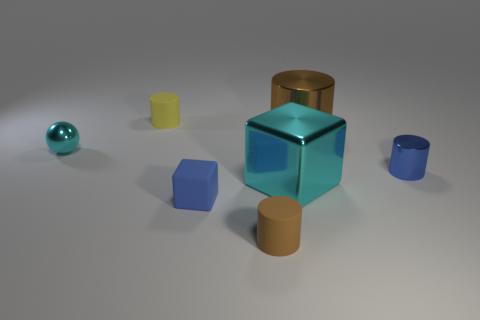Subtract 1 cylinders. How many cylinders are left? 3 Subtract all brown balls. Subtract all green cylinders. How many balls are left? 1 Add 1 cylinders. How many objects exist? 8 Subtract all cylinders. How many objects are left? 3 Subtract all tiny gray rubber cylinders. Subtract all yellow things. How many objects are left? 6 Add 3 small yellow matte cylinders. How many small yellow matte cylinders are left? 4 Add 7 big metallic cylinders. How many big metallic cylinders exist? 8 Subtract 0 gray spheres. How many objects are left? 7 